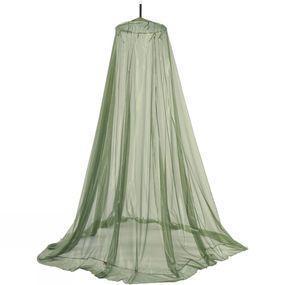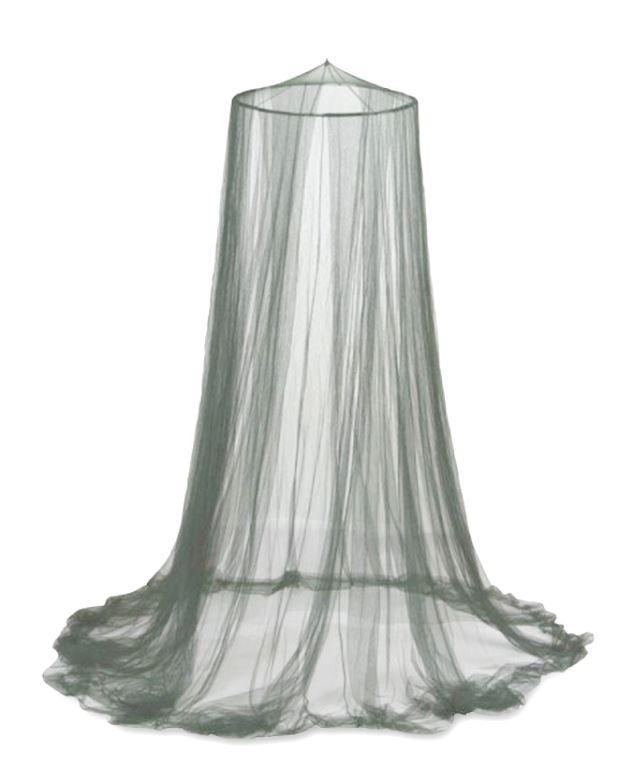The first image is the image on the left, the second image is the image on the right. Given the left and right images, does the statement "None of these bed canopies are presently covering a regular, rectangular bed." hold true? Answer yes or no. Yes. 